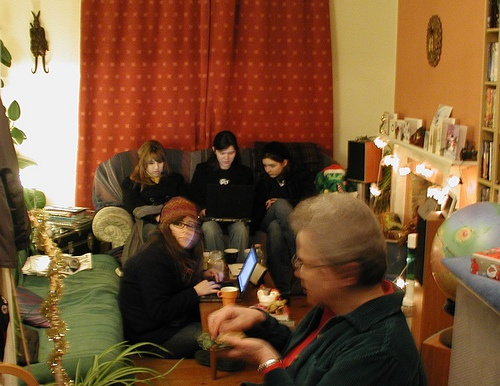Describe the objects in this image and their specific colors. I can see people in khaki, black, maroon, and brown tones, couch in khaki, olive, and black tones, people in khaki, black, maroon, brown, and tan tones, people in khaki, black, and gray tones, and people in khaki, black, olive, and maroon tones in this image. 